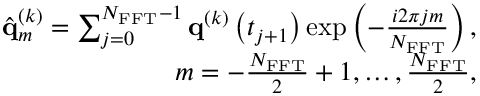<formula> <loc_0><loc_0><loc_500><loc_500>\begin{array} { r } { \hat { q } _ { m } ^ { \left ( k \right ) } = \sum _ { j = 0 } ^ { N _ { F F T } - 1 } { q } ^ { \left ( k \right ) } \left ( t _ { j + 1 } \right ) \exp \left ( - \frac { i 2 \pi j m } { N _ { F F T } } \right ) , } \\ { m = - \frac { N _ { F F T } } { 2 } + 1 , \dots , \frac { N _ { F F T } } { 2 } , } \end{array}</formula> 